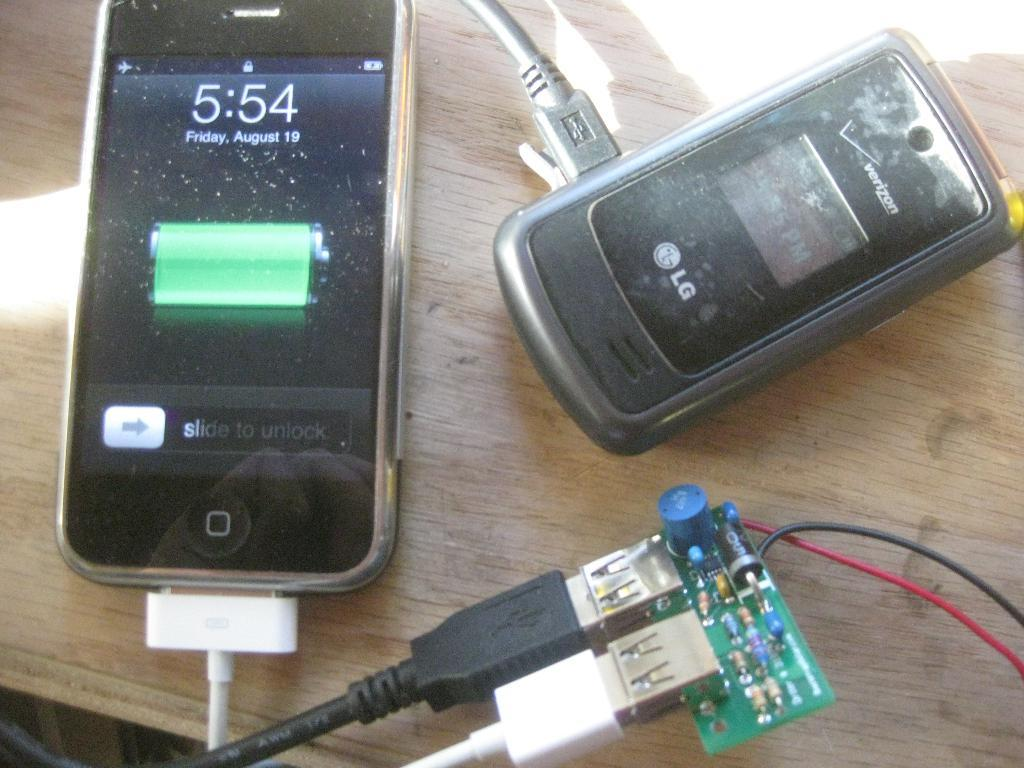<image>
Relay a brief, clear account of the picture shown. Two cell phones sitting on a table one with a battery display and the time 5:54 and an LG flipphone. 